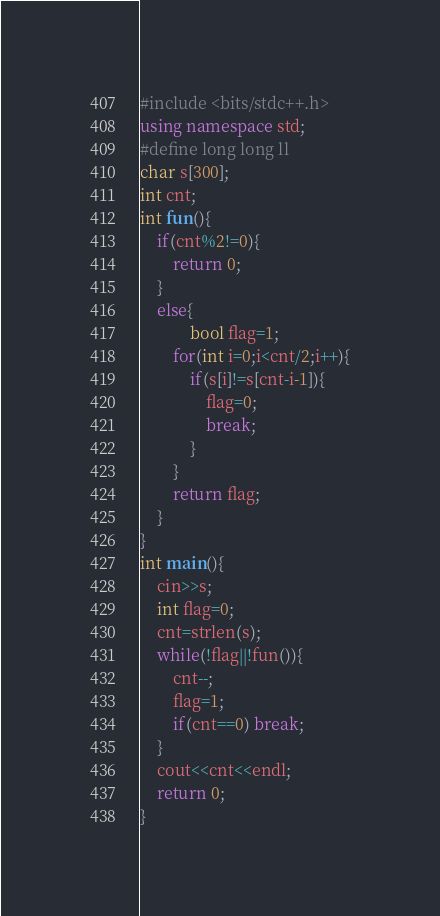<code> <loc_0><loc_0><loc_500><loc_500><_C++_>#include <bits/stdc++.h>
using namespace std;
#define long long ll
char s[300];
int cnt;
int fun(){
    if(cnt%2!=0){
        return 0;
    }
    else{
            bool flag=1;
        for(int i=0;i<cnt/2;i++){
            if(s[i]!=s[cnt-i-1]){
                flag=0;
                break;
            }
        }
        return flag;
    }
}
int main(){
    cin>>s;
    int flag=0;
    cnt=strlen(s);
    while(!flag||!fun()){
        cnt--;
        flag=1;
        if(cnt==0) break;
    }
    cout<<cnt<<endl;
    return 0;
}
</code> 